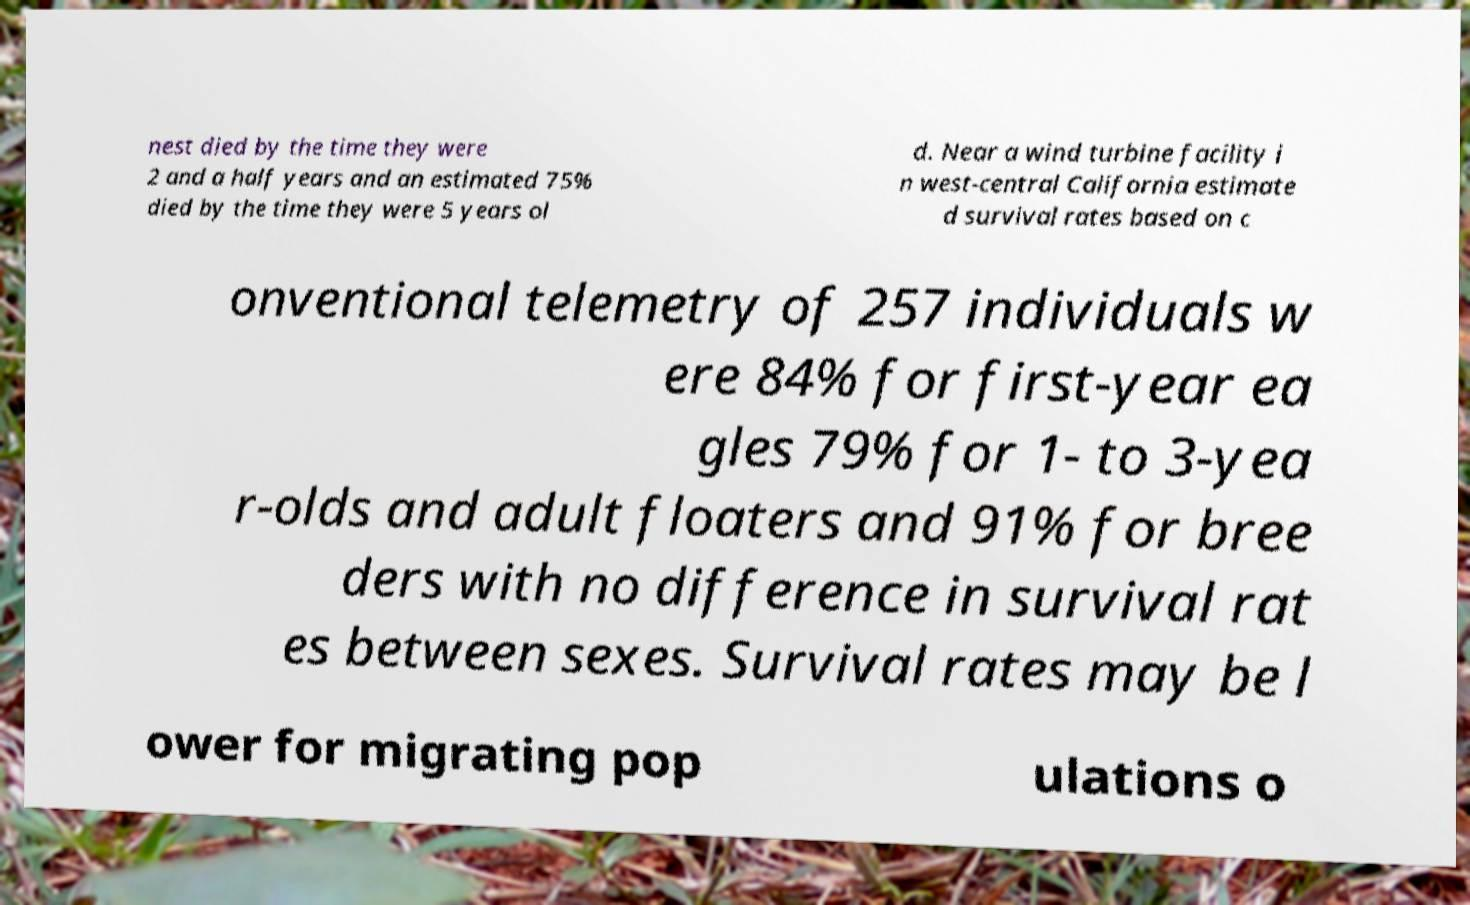Please read and relay the text visible in this image. What does it say? nest died by the time they were 2 and a half years and an estimated 75% died by the time they were 5 years ol d. Near a wind turbine facility i n west-central California estimate d survival rates based on c onventional telemetry of 257 individuals w ere 84% for first-year ea gles 79% for 1- to 3-yea r-olds and adult floaters and 91% for bree ders with no difference in survival rat es between sexes. Survival rates may be l ower for migrating pop ulations o 